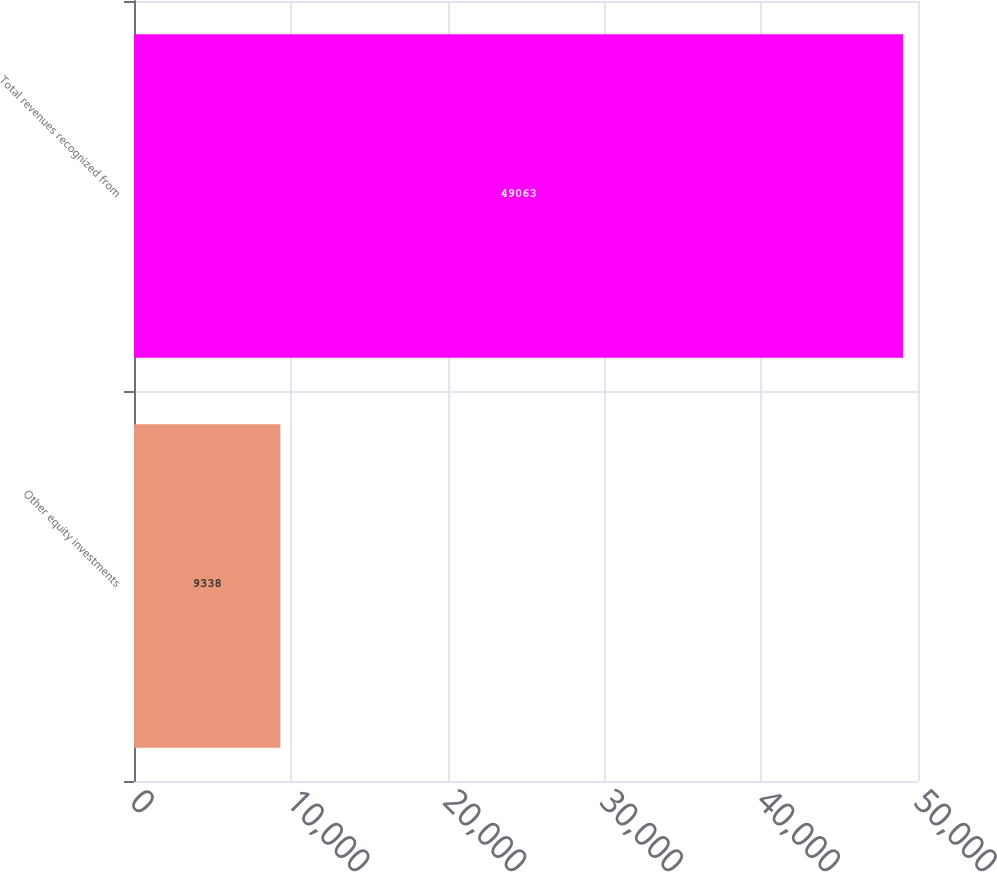<chart> <loc_0><loc_0><loc_500><loc_500><bar_chart><fcel>Other equity investments<fcel>Total revenues recognized from<nl><fcel>9338<fcel>49063<nl></chart> 